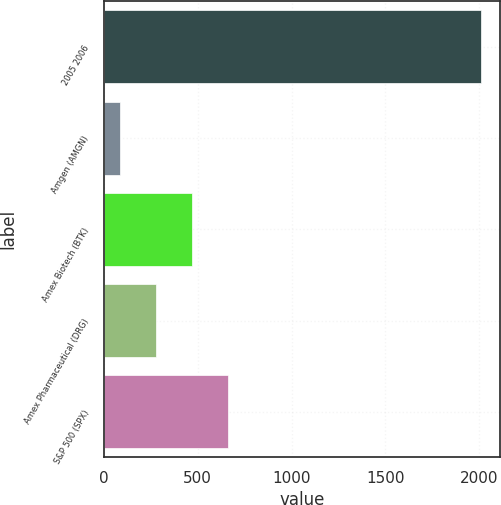Convert chart to OTSL. <chart><loc_0><loc_0><loc_500><loc_500><bar_chart><fcel>2005 2006<fcel>Amgen (AMGN)<fcel>Amex Biotech (BTK)<fcel>Amex Pharmaceutical (DRG)<fcel>S&P 500 (SPX)<nl><fcel>2008<fcel>86.62<fcel>470.9<fcel>278.76<fcel>663.04<nl></chart> 